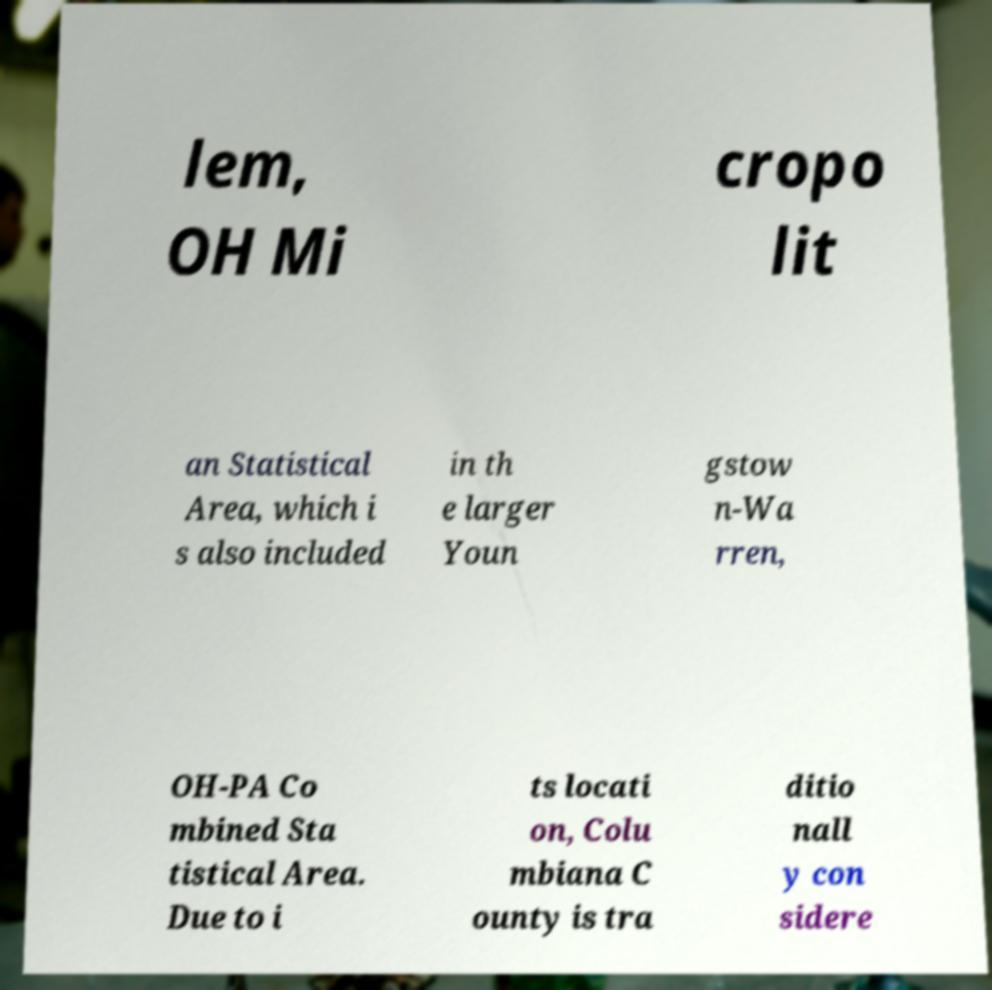Please read and relay the text visible in this image. What does it say? lem, OH Mi cropo lit an Statistical Area, which i s also included in th e larger Youn gstow n-Wa rren, OH-PA Co mbined Sta tistical Area. Due to i ts locati on, Colu mbiana C ounty is tra ditio nall y con sidere 